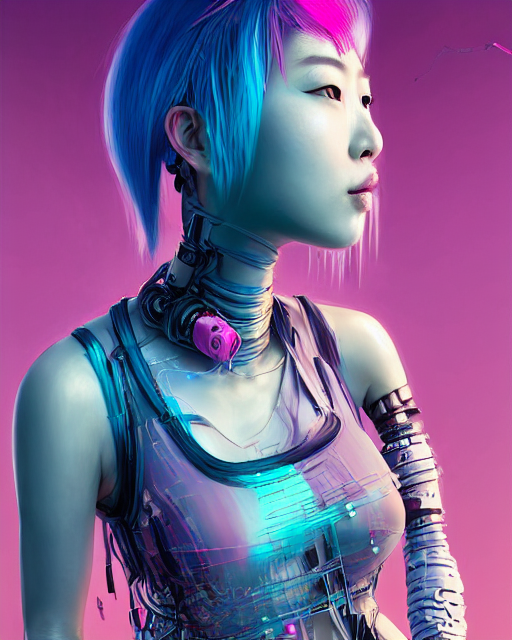What does the color palette used in this image suggest about the subject's character or mood? The color palette consisting of shades of pink and blue suggests a fusion of warmth and coolness, conveying a sense of the robot's advanced technology blended with human-like qualities. It could evoke a mood of calmness and approachability, despite the robotic nature. 